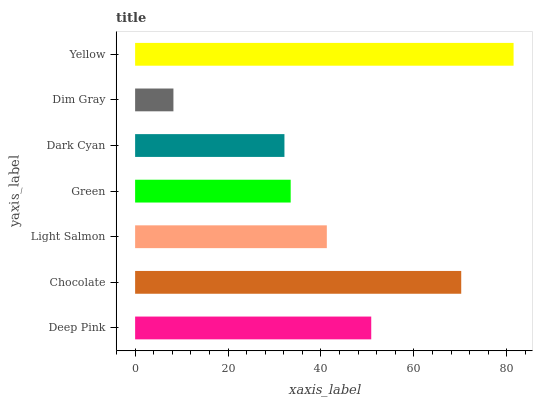Is Dim Gray the minimum?
Answer yes or no. Yes. Is Yellow the maximum?
Answer yes or no. Yes. Is Chocolate the minimum?
Answer yes or no. No. Is Chocolate the maximum?
Answer yes or no. No. Is Chocolate greater than Deep Pink?
Answer yes or no. Yes. Is Deep Pink less than Chocolate?
Answer yes or no. Yes. Is Deep Pink greater than Chocolate?
Answer yes or no. No. Is Chocolate less than Deep Pink?
Answer yes or no. No. Is Light Salmon the high median?
Answer yes or no. Yes. Is Light Salmon the low median?
Answer yes or no. Yes. Is Dark Cyan the high median?
Answer yes or no. No. Is Chocolate the low median?
Answer yes or no. No. 